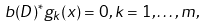Convert formula to latex. <formula><loc_0><loc_0><loc_500><loc_500>b ( D ) ^ { * } g _ { k } ( x ) = 0 , k = 1 , \dots , m ,</formula> 